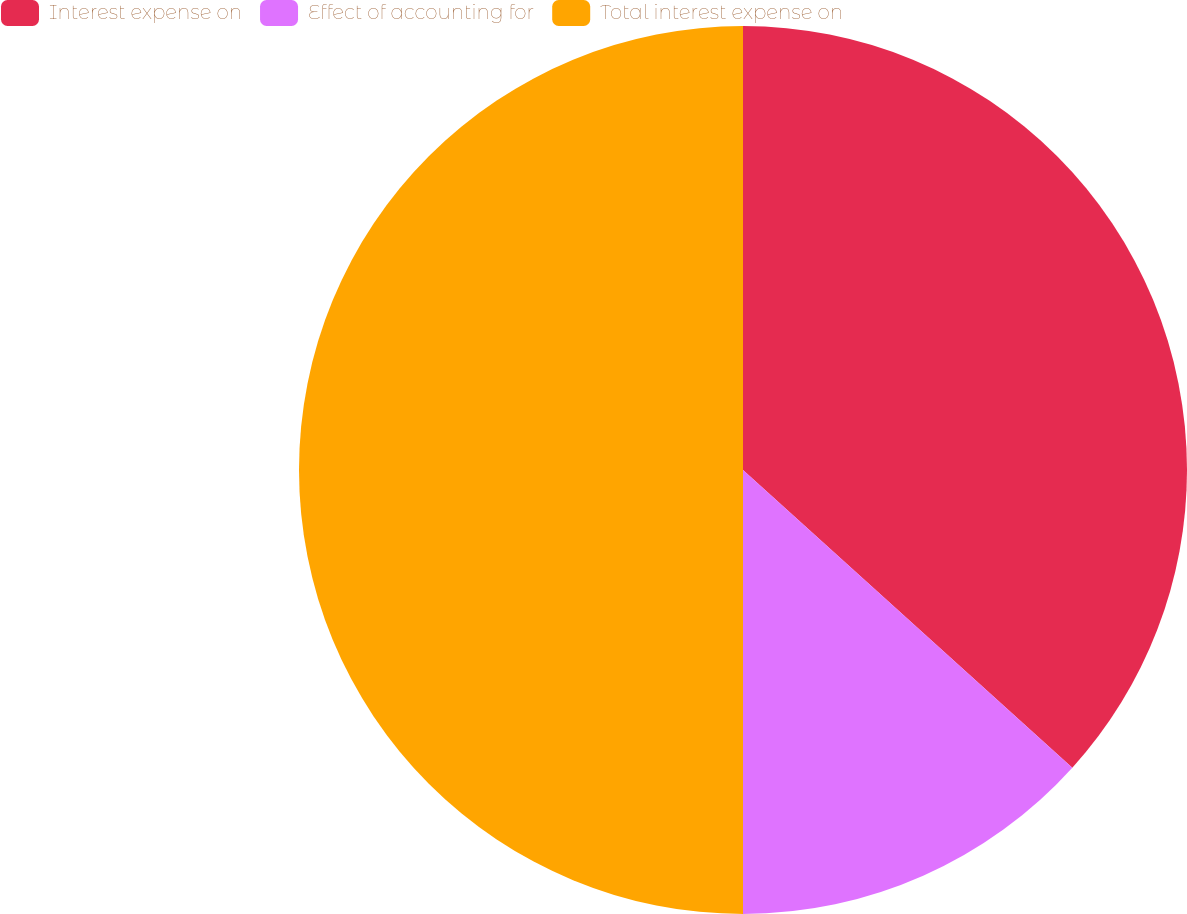Convert chart to OTSL. <chart><loc_0><loc_0><loc_500><loc_500><pie_chart><fcel>Interest expense on<fcel>Effect of accounting for<fcel>Total interest expense on<nl><fcel>36.7%<fcel>13.3%<fcel>50.0%<nl></chart> 